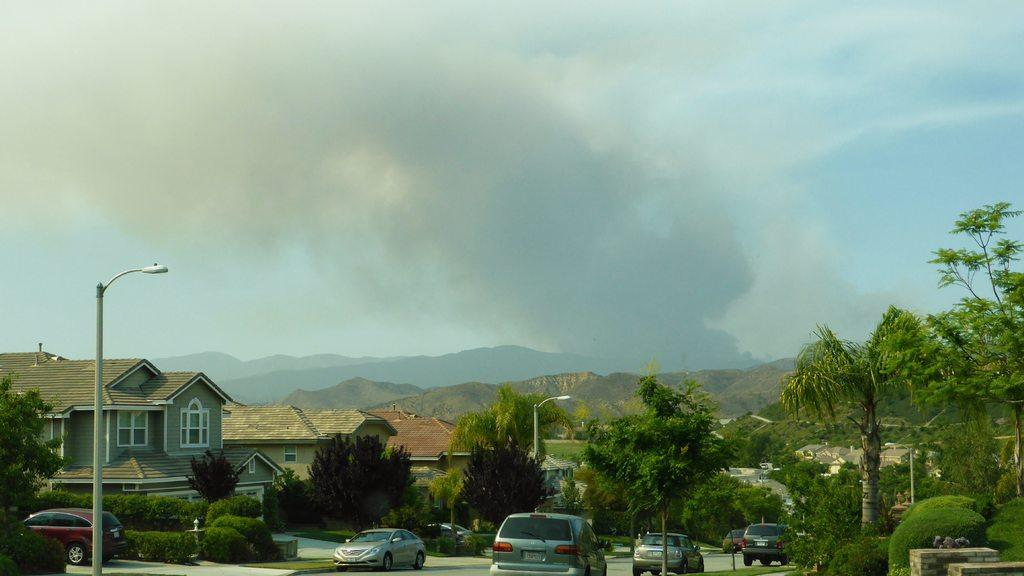What types of structures can be seen in the image? There are houses and poles in the image. What other objects can be seen in the image? There are vehicles, trees, plants, lights, and windows in the image. What natural features are visible in the image? There are mountains in the image. What can be seen in the background of the image? The sky is visible in the background of the image, and clouds are present in the sky. What type of lace is draped over the mountains in the image? There is no lace present in the image; it features houses, vehicles, trees, plants, lights, windows, mountains, and a sky with clouds. Can you see a man in the image? There is no man present in the image. 